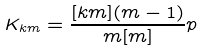<formula> <loc_0><loc_0><loc_500><loc_500>K _ { k m } = \frac { [ k m ] ( m - 1 ) } { m [ m ] } p</formula> 